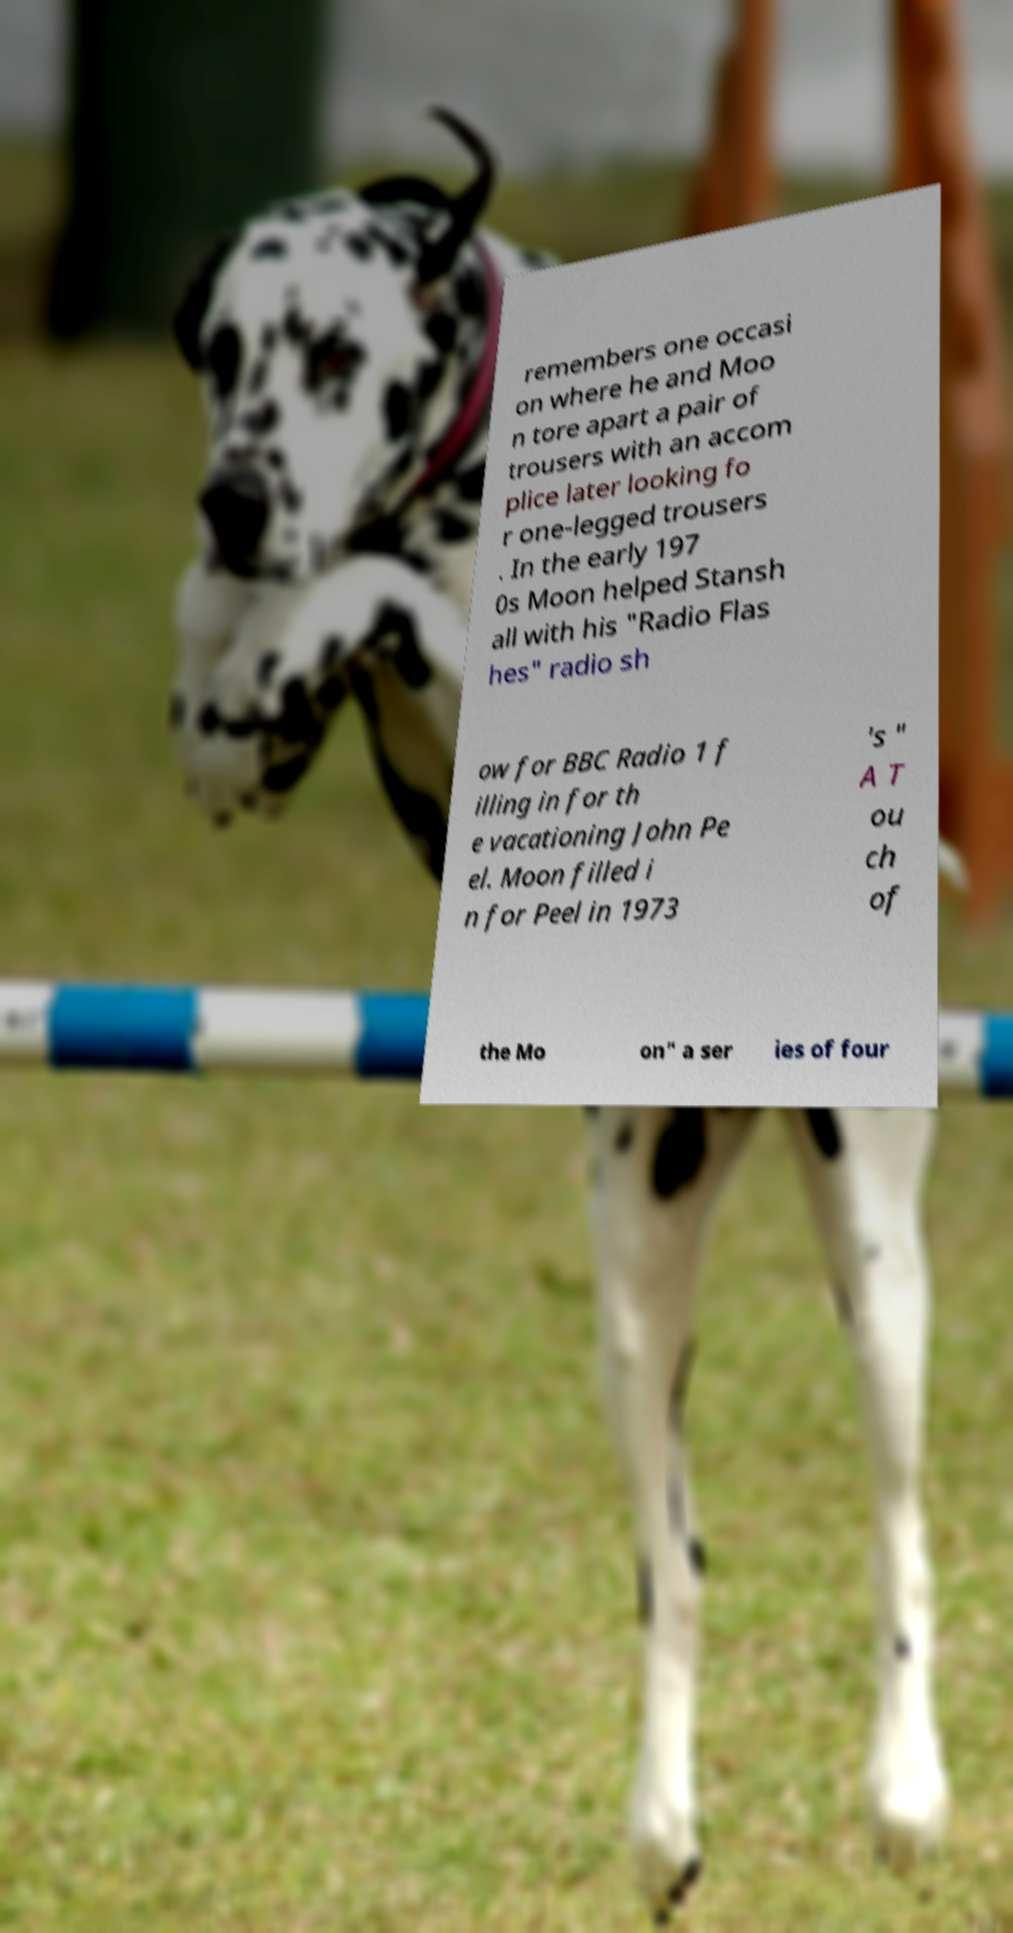Could you extract and type out the text from this image? remembers one occasi on where he and Moo n tore apart a pair of trousers with an accom plice later looking fo r one-legged trousers . In the early 197 0s Moon helped Stansh all with his "Radio Flas hes" radio sh ow for BBC Radio 1 f illing in for th e vacationing John Pe el. Moon filled i n for Peel in 1973 's " A T ou ch of the Mo on" a ser ies of four 